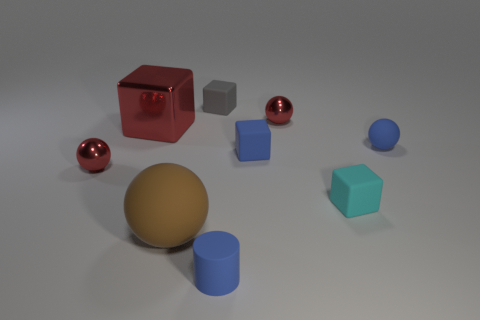How many large metal things are the same color as the tiny matte ball?
Your response must be concise. 0. What size is the gray cube that is the same material as the cyan cube?
Give a very brief answer. Small. How many things are blue spheres or purple metal things?
Your answer should be very brief. 1. What is the color of the thing in front of the brown matte thing?
Give a very brief answer. Blue. There is a cyan matte object that is the same shape as the small gray matte object; what size is it?
Ensure brevity in your answer.  Small. What number of things are either metallic spheres to the left of the big brown sphere or tiny things behind the small cyan matte thing?
Provide a short and direct response. 5. There is a red thing that is left of the brown rubber object and behind the tiny blue block; how big is it?
Offer a very short reply. Large. Is the shape of the small gray object the same as the small red object that is in front of the shiny block?
Your response must be concise. No. What number of objects are spheres on the right side of the tiny blue cube or large cyan metal cubes?
Give a very brief answer. 2. Do the tiny cyan object and the sphere to the right of the cyan cube have the same material?
Provide a succinct answer. Yes. 